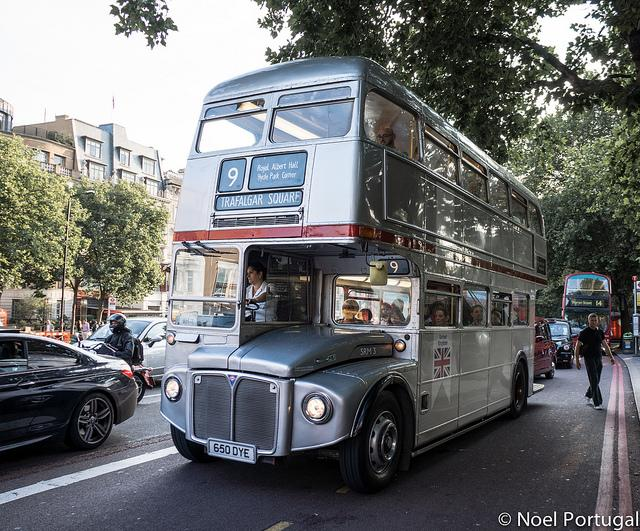In which country does this bus drive? england 